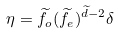<formula> <loc_0><loc_0><loc_500><loc_500>\eta = \widetilde { f } _ { o } ( \widetilde { f } _ { e } ) ^ { \widetilde { d } - 2 } \delta</formula> 